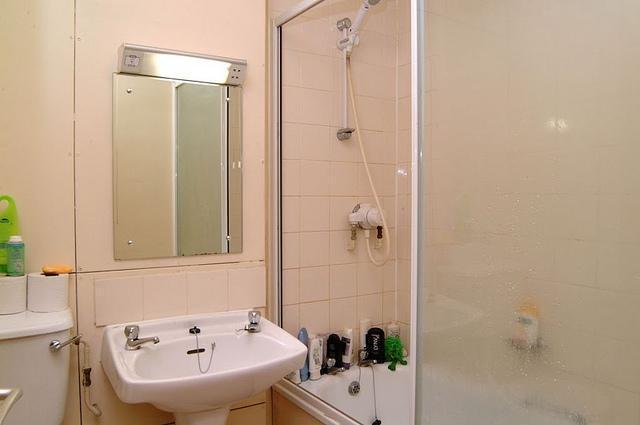How many mirrors are in the picture?
Give a very brief answer. 1. 